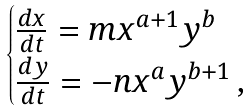<formula> <loc_0><loc_0><loc_500><loc_500>\begin{cases} \frac { d x } { d t } = m x ^ { a + 1 } y ^ { b } \\ \frac { d y } { d t } = - n x ^ { a } y ^ { b + 1 } \, , \end{cases}</formula> 